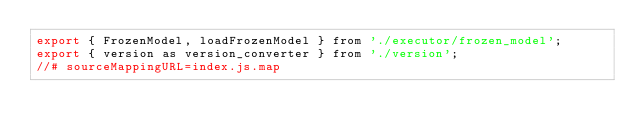Convert code to text. <code><loc_0><loc_0><loc_500><loc_500><_JavaScript_>export { FrozenModel, loadFrozenModel } from './executor/frozen_model';
export { version as version_converter } from './version';
//# sourceMappingURL=index.js.map</code> 